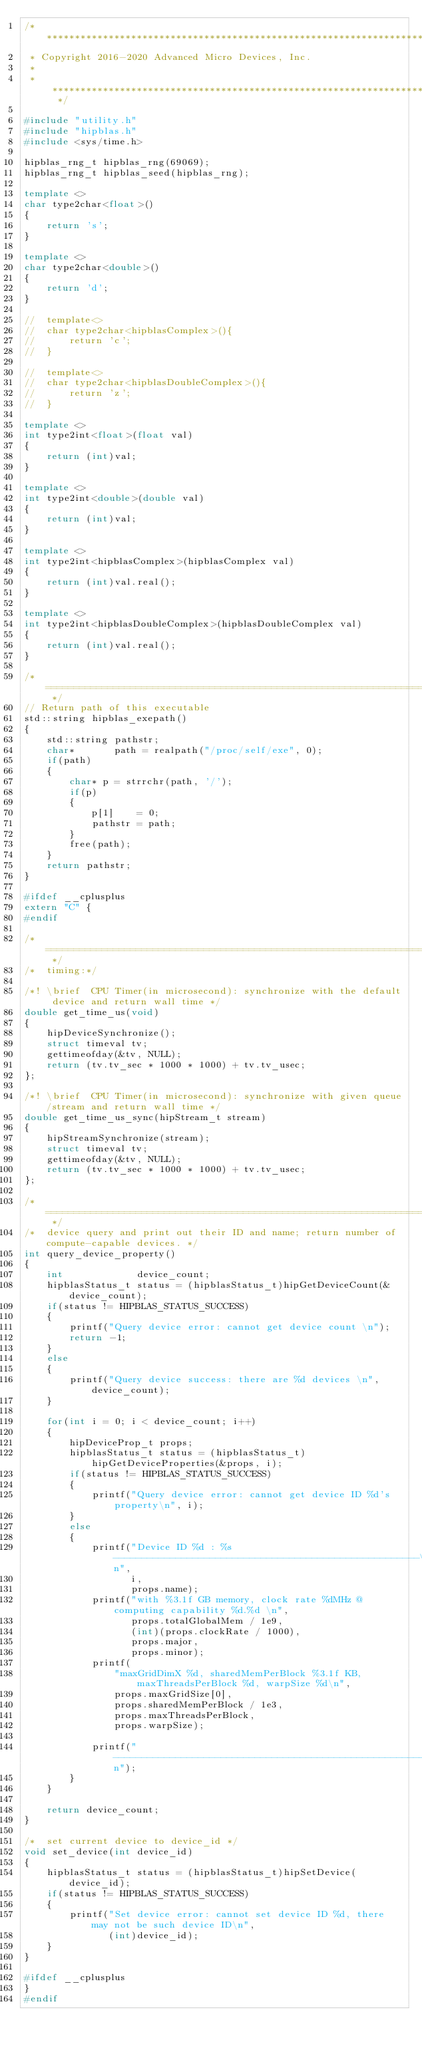Convert code to text. <code><loc_0><loc_0><loc_500><loc_500><_C++_>/* ************************************************************************
 * Copyright 2016-2020 Advanced Micro Devices, Inc.
 *
 * ************************************************************************ */

#include "utility.h"
#include "hipblas.h"
#include <sys/time.h>

hipblas_rng_t hipblas_rng(69069);
hipblas_rng_t hipblas_seed(hipblas_rng);

template <>
char type2char<float>()
{
    return 's';
}

template <>
char type2char<double>()
{
    return 'd';
}

//  template<>
//  char type2char<hipblasComplex>(){
//      return 'c';
//  }

//  template<>
//  char type2char<hipblasDoubleComplex>(){
//      return 'z';
//  }

template <>
int type2int<float>(float val)
{
    return (int)val;
}

template <>
int type2int<double>(double val)
{
    return (int)val;
}

template <>
int type2int<hipblasComplex>(hipblasComplex val)
{
    return (int)val.real();
}

template <>
int type2int<hipblasDoubleComplex>(hipblasDoubleComplex val)
{
    return (int)val.real();
}

/* ============================================================================================ */
// Return path of this executable
std::string hipblas_exepath()
{
    std::string pathstr;
    char*       path = realpath("/proc/self/exe", 0);
    if(path)
    {
        char* p = strrchr(path, '/');
        if(p)
        {
            p[1]    = 0;
            pathstr = path;
        }
        free(path);
    }
    return pathstr;
}

#ifdef __cplusplus
extern "C" {
#endif

/* ============================================================================================ */
/*  timing:*/

/*! \brief  CPU Timer(in microsecond): synchronize with the default device and return wall time */
double get_time_us(void)
{
    hipDeviceSynchronize();
    struct timeval tv;
    gettimeofday(&tv, NULL);
    return (tv.tv_sec * 1000 * 1000) + tv.tv_usec;
};

/*! \brief  CPU Timer(in microsecond): synchronize with given queue/stream and return wall time */
double get_time_us_sync(hipStream_t stream)
{
    hipStreamSynchronize(stream);
    struct timeval tv;
    gettimeofday(&tv, NULL);
    return (tv.tv_sec * 1000 * 1000) + tv.tv_usec;
};

/* ============================================================================================ */
/*  device query and print out their ID and name; return number of compute-capable devices. */
int query_device_property()
{
    int             device_count;
    hipblasStatus_t status = (hipblasStatus_t)hipGetDeviceCount(&device_count);
    if(status != HIPBLAS_STATUS_SUCCESS)
    {
        printf("Query device error: cannot get device count \n");
        return -1;
    }
    else
    {
        printf("Query device success: there are %d devices \n", device_count);
    }

    for(int i = 0; i < device_count; i++)
    {
        hipDeviceProp_t props;
        hipblasStatus_t status = (hipblasStatus_t)hipGetDeviceProperties(&props, i);
        if(status != HIPBLAS_STATUS_SUCCESS)
        {
            printf("Query device error: cannot get device ID %d's property\n", i);
        }
        else
        {
            printf("Device ID %d : %s ------------------------------------------------------\n",
                   i,
                   props.name);
            printf("with %3.1f GB memory, clock rate %dMHz @ computing capability %d.%d \n",
                   props.totalGlobalMem / 1e9,
                   (int)(props.clockRate / 1000),
                   props.major,
                   props.minor);
            printf(
                "maxGridDimX %d, sharedMemPerBlock %3.1f KB, maxThreadsPerBlock %d, warpSize %d\n",
                props.maxGridSize[0],
                props.sharedMemPerBlock / 1e3,
                props.maxThreadsPerBlock,
                props.warpSize);

            printf("-------------------------------------------------------------------------\n");
        }
    }

    return device_count;
}

/*  set current device to device_id */
void set_device(int device_id)
{
    hipblasStatus_t status = (hipblasStatus_t)hipSetDevice(device_id);
    if(status != HIPBLAS_STATUS_SUCCESS)
    {
        printf("Set device error: cannot set device ID %d, there may not be such device ID\n",
               (int)device_id);
    }
}

#ifdef __cplusplus
}
#endif
</code> 